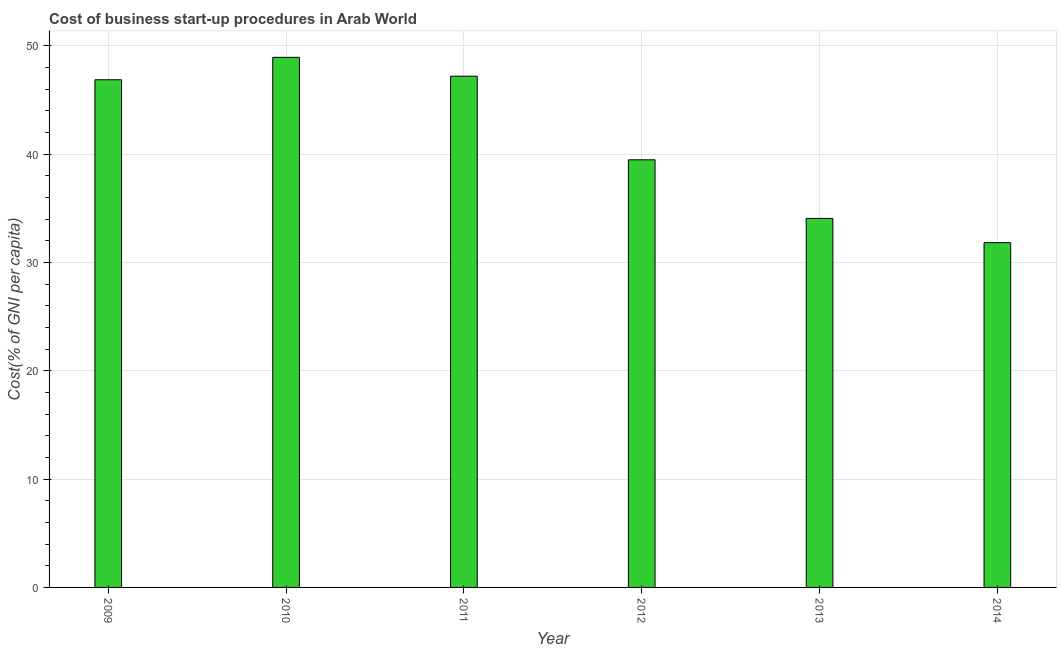Does the graph contain any zero values?
Provide a short and direct response. No. Does the graph contain grids?
Ensure brevity in your answer.  Yes. What is the title of the graph?
Offer a terse response. Cost of business start-up procedures in Arab World. What is the label or title of the X-axis?
Offer a very short reply. Year. What is the label or title of the Y-axis?
Your response must be concise. Cost(% of GNI per capita). What is the cost of business startup procedures in 2013?
Make the answer very short. 34.06. Across all years, what is the maximum cost of business startup procedures?
Keep it short and to the point. 48.92. Across all years, what is the minimum cost of business startup procedures?
Offer a very short reply. 31.82. In which year was the cost of business startup procedures maximum?
Offer a terse response. 2010. In which year was the cost of business startup procedures minimum?
Give a very brief answer. 2014. What is the sum of the cost of business startup procedures?
Your answer should be compact. 248.31. What is the difference between the cost of business startup procedures in 2010 and 2014?
Ensure brevity in your answer.  17.11. What is the average cost of business startup procedures per year?
Your response must be concise. 41.38. What is the median cost of business startup procedures?
Your answer should be very brief. 43.16. In how many years, is the cost of business startup procedures greater than 34 %?
Your answer should be compact. 5. Do a majority of the years between 2011 and 2012 (inclusive) have cost of business startup procedures greater than 36 %?
Your answer should be compact. Yes. What is the ratio of the cost of business startup procedures in 2013 to that in 2014?
Provide a succinct answer. 1.07. Is the cost of business startup procedures in 2009 less than that in 2014?
Give a very brief answer. No. What is the difference between the highest and the second highest cost of business startup procedures?
Your response must be concise. 1.74. Is the sum of the cost of business startup procedures in 2011 and 2012 greater than the maximum cost of business startup procedures across all years?
Provide a succinct answer. Yes. What is the difference between the highest and the lowest cost of business startup procedures?
Offer a very short reply. 17.11. In how many years, is the cost of business startup procedures greater than the average cost of business startup procedures taken over all years?
Your answer should be very brief. 3. How many bars are there?
Your answer should be very brief. 6. Are all the bars in the graph horizontal?
Keep it short and to the point. No. How many years are there in the graph?
Provide a short and direct response. 6. What is the difference between two consecutive major ticks on the Y-axis?
Provide a short and direct response. 10. What is the Cost(% of GNI per capita) of 2009?
Keep it short and to the point. 46.85. What is the Cost(% of GNI per capita) of 2010?
Provide a succinct answer. 48.92. What is the Cost(% of GNI per capita) of 2011?
Give a very brief answer. 47.19. What is the Cost(% of GNI per capita) in 2012?
Keep it short and to the point. 39.47. What is the Cost(% of GNI per capita) in 2013?
Your answer should be compact. 34.06. What is the Cost(% of GNI per capita) of 2014?
Provide a short and direct response. 31.82. What is the difference between the Cost(% of GNI per capita) in 2009 and 2010?
Provide a short and direct response. -2.07. What is the difference between the Cost(% of GNI per capita) in 2009 and 2011?
Keep it short and to the point. -0.33. What is the difference between the Cost(% of GNI per capita) in 2009 and 2012?
Keep it short and to the point. 7.39. What is the difference between the Cost(% of GNI per capita) in 2009 and 2013?
Your answer should be compact. 12.8. What is the difference between the Cost(% of GNI per capita) in 2009 and 2014?
Offer a terse response. 15.04. What is the difference between the Cost(% of GNI per capita) in 2010 and 2011?
Your answer should be compact. 1.74. What is the difference between the Cost(% of GNI per capita) in 2010 and 2012?
Offer a terse response. 9.46. What is the difference between the Cost(% of GNI per capita) in 2010 and 2013?
Ensure brevity in your answer.  14.87. What is the difference between the Cost(% of GNI per capita) in 2010 and 2014?
Offer a very short reply. 17.11. What is the difference between the Cost(% of GNI per capita) in 2011 and 2012?
Your response must be concise. 7.72. What is the difference between the Cost(% of GNI per capita) in 2011 and 2013?
Your answer should be compact. 13.13. What is the difference between the Cost(% of GNI per capita) in 2011 and 2014?
Make the answer very short. 15.37. What is the difference between the Cost(% of GNI per capita) in 2012 and 2013?
Provide a succinct answer. 5.41. What is the difference between the Cost(% of GNI per capita) in 2012 and 2014?
Offer a terse response. 7.65. What is the difference between the Cost(% of GNI per capita) in 2013 and 2014?
Your response must be concise. 2.24. What is the ratio of the Cost(% of GNI per capita) in 2009 to that in 2010?
Offer a terse response. 0.96. What is the ratio of the Cost(% of GNI per capita) in 2009 to that in 2012?
Keep it short and to the point. 1.19. What is the ratio of the Cost(% of GNI per capita) in 2009 to that in 2013?
Make the answer very short. 1.38. What is the ratio of the Cost(% of GNI per capita) in 2009 to that in 2014?
Your answer should be very brief. 1.47. What is the ratio of the Cost(% of GNI per capita) in 2010 to that in 2011?
Your response must be concise. 1.04. What is the ratio of the Cost(% of GNI per capita) in 2010 to that in 2012?
Your answer should be compact. 1.24. What is the ratio of the Cost(% of GNI per capita) in 2010 to that in 2013?
Make the answer very short. 1.44. What is the ratio of the Cost(% of GNI per capita) in 2010 to that in 2014?
Make the answer very short. 1.54. What is the ratio of the Cost(% of GNI per capita) in 2011 to that in 2012?
Provide a short and direct response. 1.2. What is the ratio of the Cost(% of GNI per capita) in 2011 to that in 2013?
Your answer should be very brief. 1.39. What is the ratio of the Cost(% of GNI per capita) in 2011 to that in 2014?
Provide a short and direct response. 1.48. What is the ratio of the Cost(% of GNI per capita) in 2012 to that in 2013?
Give a very brief answer. 1.16. What is the ratio of the Cost(% of GNI per capita) in 2012 to that in 2014?
Your answer should be compact. 1.24. What is the ratio of the Cost(% of GNI per capita) in 2013 to that in 2014?
Your answer should be very brief. 1.07. 